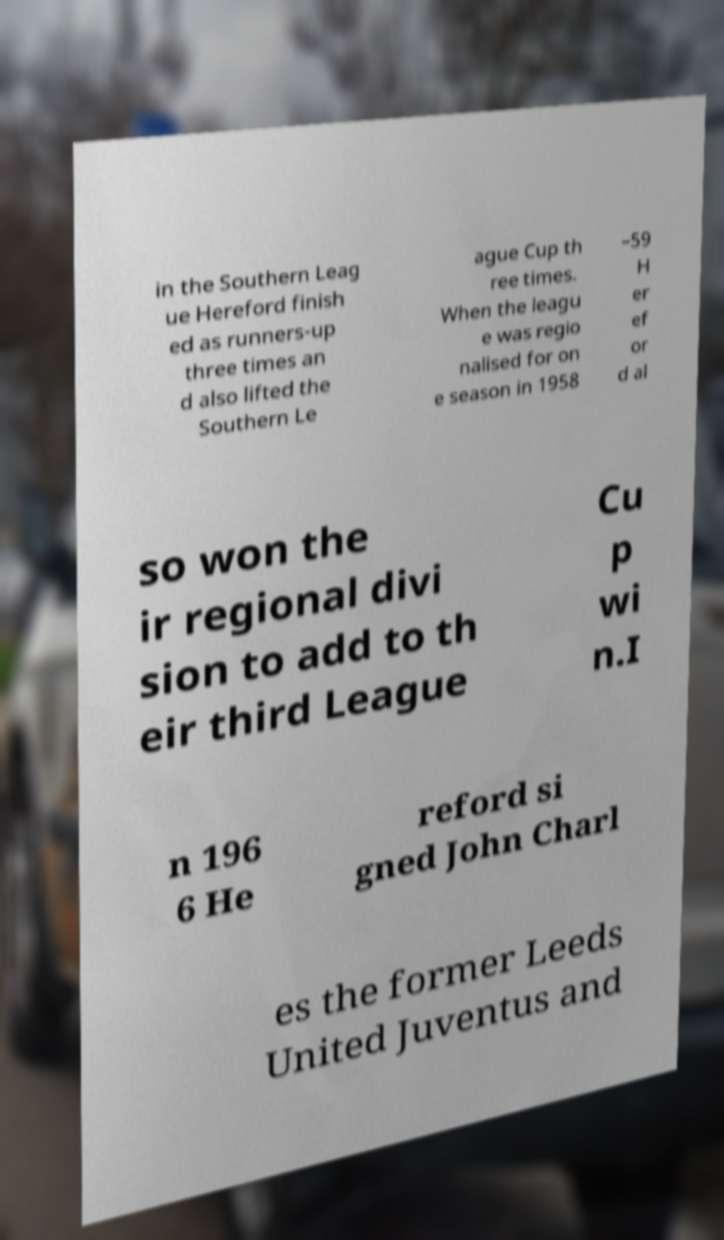What messages or text are displayed in this image? I need them in a readable, typed format. in the Southern Leag ue Hereford finish ed as runners-up three times an d also lifted the Southern Le ague Cup th ree times. When the leagu e was regio nalised for on e season in 1958 –59 H er ef or d al so won the ir regional divi sion to add to th eir third League Cu p wi n.I n 196 6 He reford si gned John Charl es the former Leeds United Juventus and 